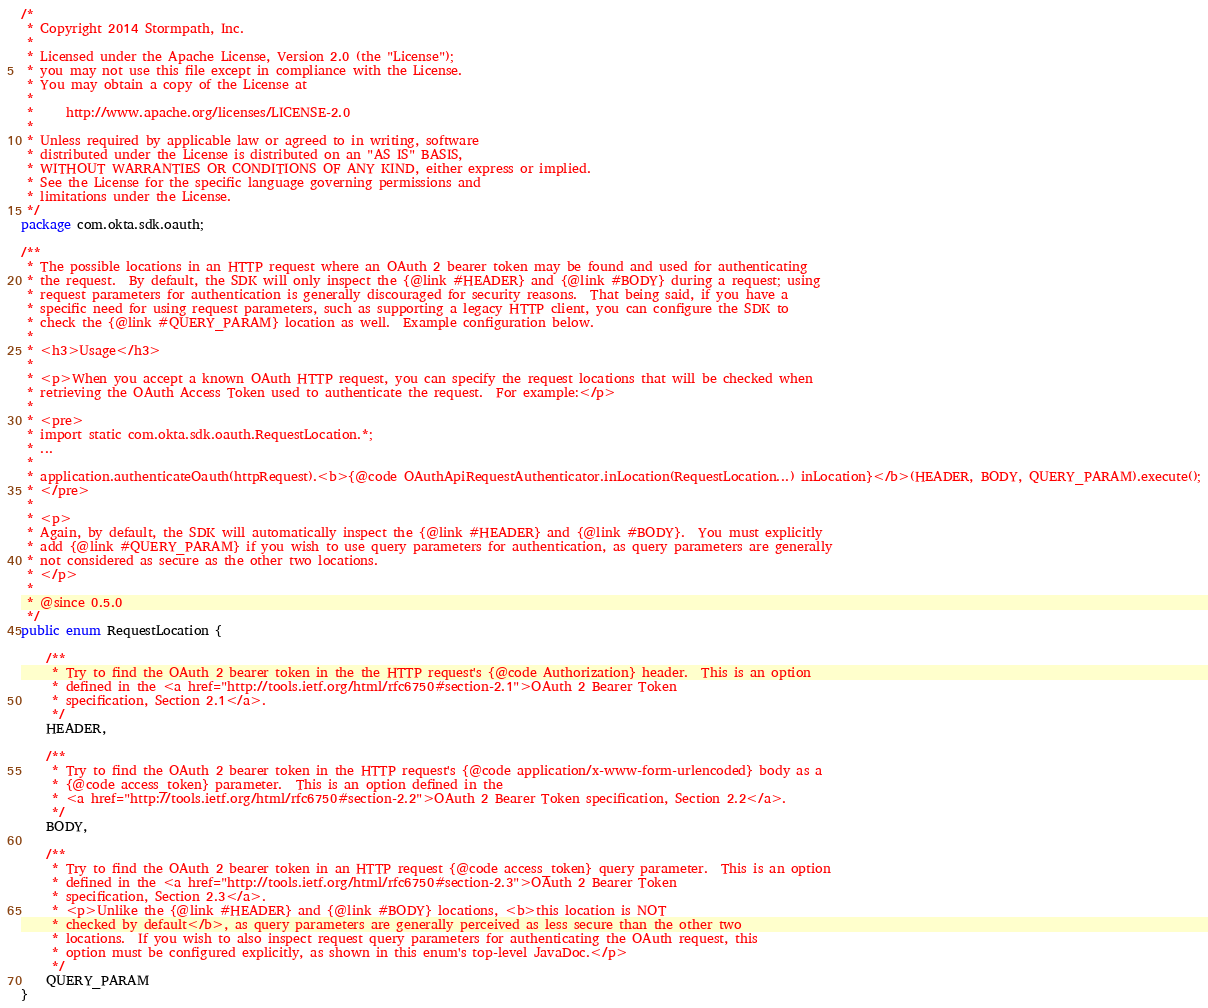Convert code to text. <code><loc_0><loc_0><loc_500><loc_500><_Java_>/*
 * Copyright 2014 Stormpath, Inc.
 *
 * Licensed under the Apache License, Version 2.0 (the "License");
 * you may not use this file except in compliance with the License.
 * You may obtain a copy of the License at
 *
 *     http://www.apache.org/licenses/LICENSE-2.0
 *
 * Unless required by applicable law or agreed to in writing, software
 * distributed under the License is distributed on an "AS IS" BASIS,
 * WITHOUT WARRANTIES OR CONDITIONS OF ANY KIND, either express or implied.
 * See the License for the specific language governing permissions and
 * limitations under the License.
 */
package com.okta.sdk.oauth;

/**
 * The possible locations in an HTTP request where an OAuth 2 bearer token may be found and used for authenticating
 * the request.  By default, the SDK will only inspect the {@link #HEADER} and {@link #BODY} during a request; using
 * request parameters for authentication is generally discouraged for security reasons.  That being said, if you have a
 * specific need for using request parameters, such as supporting a legacy HTTP client, you can configure the SDK to
 * check the {@link #QUERY_PARAM} location as well.  Example configuration below.
 *
 * <h3>Usage</h3>
 *
 * <p>When you accept a known OAuth HTTP request, you can specify the request locations that will be checked when
 * retrieving the OAuth Access Token used to authenticate the request.  For example:</p>
 *
 * <pre>
 * import static com.okta.sdk.oauth.RequestLocation.*;
 * ...
 *
 * application.authenticateOauth(httpRequest).<b>{@code OAuthApiRequestAuthenticator.inLocation(RequestLocation...) inLocation}</b>(HEADER, BODY, QUERY_PARAM).execute();
 * </pre>
 *
 * <p>
 * Again, by default, the SDK will automatically inspect the {@link #HEADER} and {@link #BODY}.  You must explicitly
 * add {@link #QUERY_PARAM} if you wish to use query parameters for authentication, as query parameters are generally
 * not considered as secure as the other two locations.
 * </p>
 *
 * @since 0.5.0
 */
public enum RequestLocation {

    /**
     * Try to find the OAuth 2 bearer token in the the HTTP request's {@code Authorization} header.  This is an option
     * defined in the <a href="http://tools.ietf.org/html/rfc6750#section-2.1">OAuth 2 Bearer Token
     * specification, Section 2.1</a>.
     */
    HEADER,

    /**
     * Try to find the OAuth 2 bearer token in the HTTP request's {@code application/x-www-form-urlencoded} body as a
     * {@code access_token} parameter.  This is an option defined in the
     * <a href="http://tools.ietf.org/html/rfc6750#section-2.2">OAuth 2 Bearer Token specification, Section 2.2</a>.
     */
    BODY,

    /**
     * Try to find the OAuth 2 bearer token in an HTTP request {@code access_token} query parameter.  This is an option
     * defined in the <a href="http://tools.ietf.org/html/rfc6750#section-2.3">OAuth 2 Bearer Token
     * specification, Section 2.3</a>.
     * <p>Unlike the {@link #HEADER} and {@link #BODY} locations, <b>this location is NOT
     * checked by default</b>, as query parameters are generally perceived as less secure than the other two
     * locations.  If you wish to also inspect request query parameters for authenticating the OAuth request, this
     * option must be configured explicitly, as shown in this enum's top-level JavaDoc.</p>
     */
    QUERY_PARAM
}
</code> 